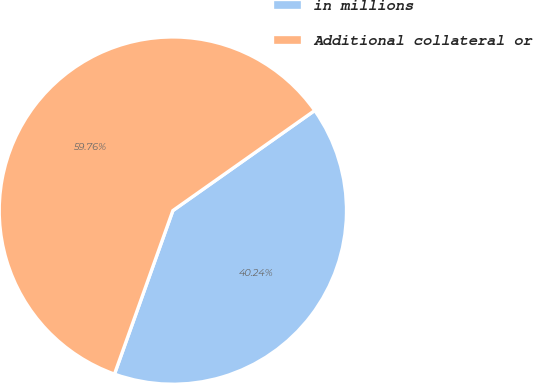<chart> <loc_0><loc_0><loc_500><loc_500><pie_chart><fcel>in millions<fcel>Additional collateral or<nl><fcel>40.24%<fcel>59.76%<nl></chart> 